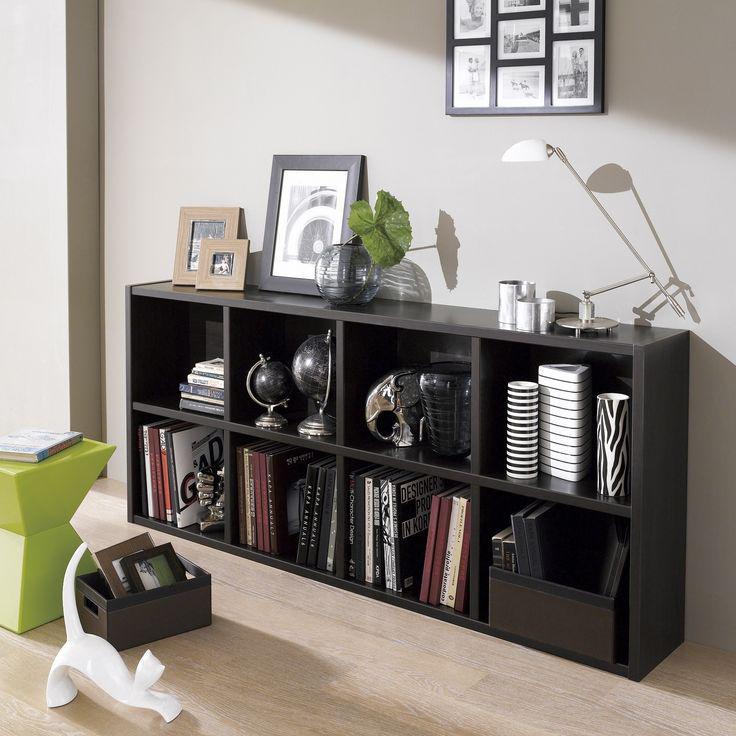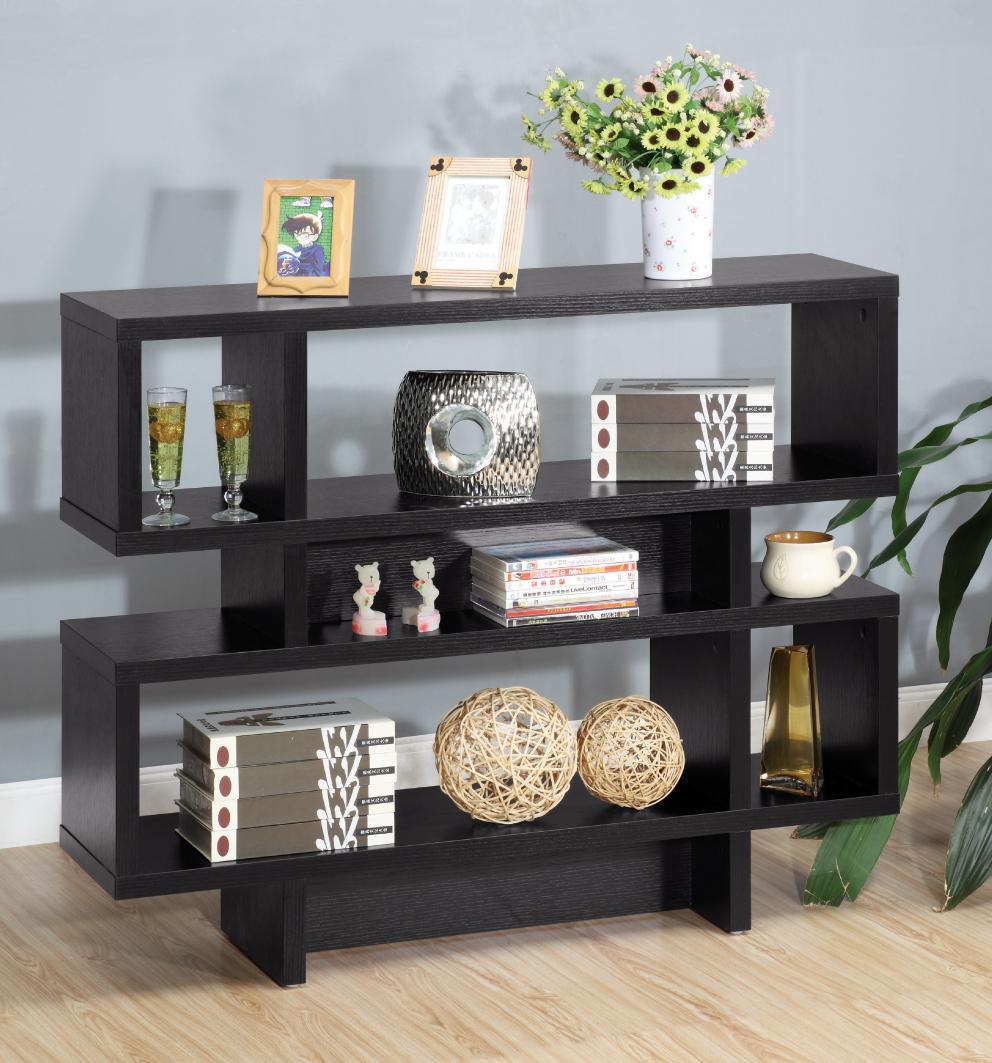The first image is the image on the left, the second image is the image on the right. Evaluate the accuracy of this statement regarding the images: "Each shelving unit is wider than it is tall and has exactly two shelf levels, but one sits flush on the floor and the other has short legs.". Is it true? Answer yes or no. No. The first image is the image on the left, the second image is the image on the right. Evaluate the accuracy of this statement regarding the images: "There is a plant on top of a shelf in at least one of the images.". Is it true? Answer yes or no. Yes. 